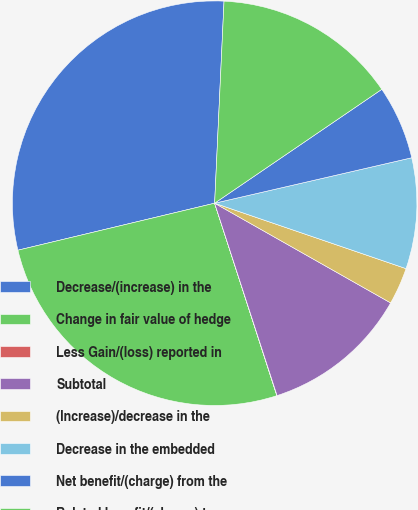<chart> <loc_0><loc_0><loc_500><loc_500><pie_chart><fcel>Decrease/(increase) in the<fcel>Change in fair value of hedge<fcel>Less Gain/(loss) reported in<fcel>Subtotal<fcel>(Increase)/decrease in the<fcel>Decrease in the embedded<fcel>Net benefit/(charge) from the<fcel>Related benefit/(charge) to<nl><fcel>29.47%<fcel>26.24%<fcel>0.02%<fcel>11.8%<fcel>2.96%<fcel>8.85%<fcel>5.91%<fcel>14.74%<nl></chart> 